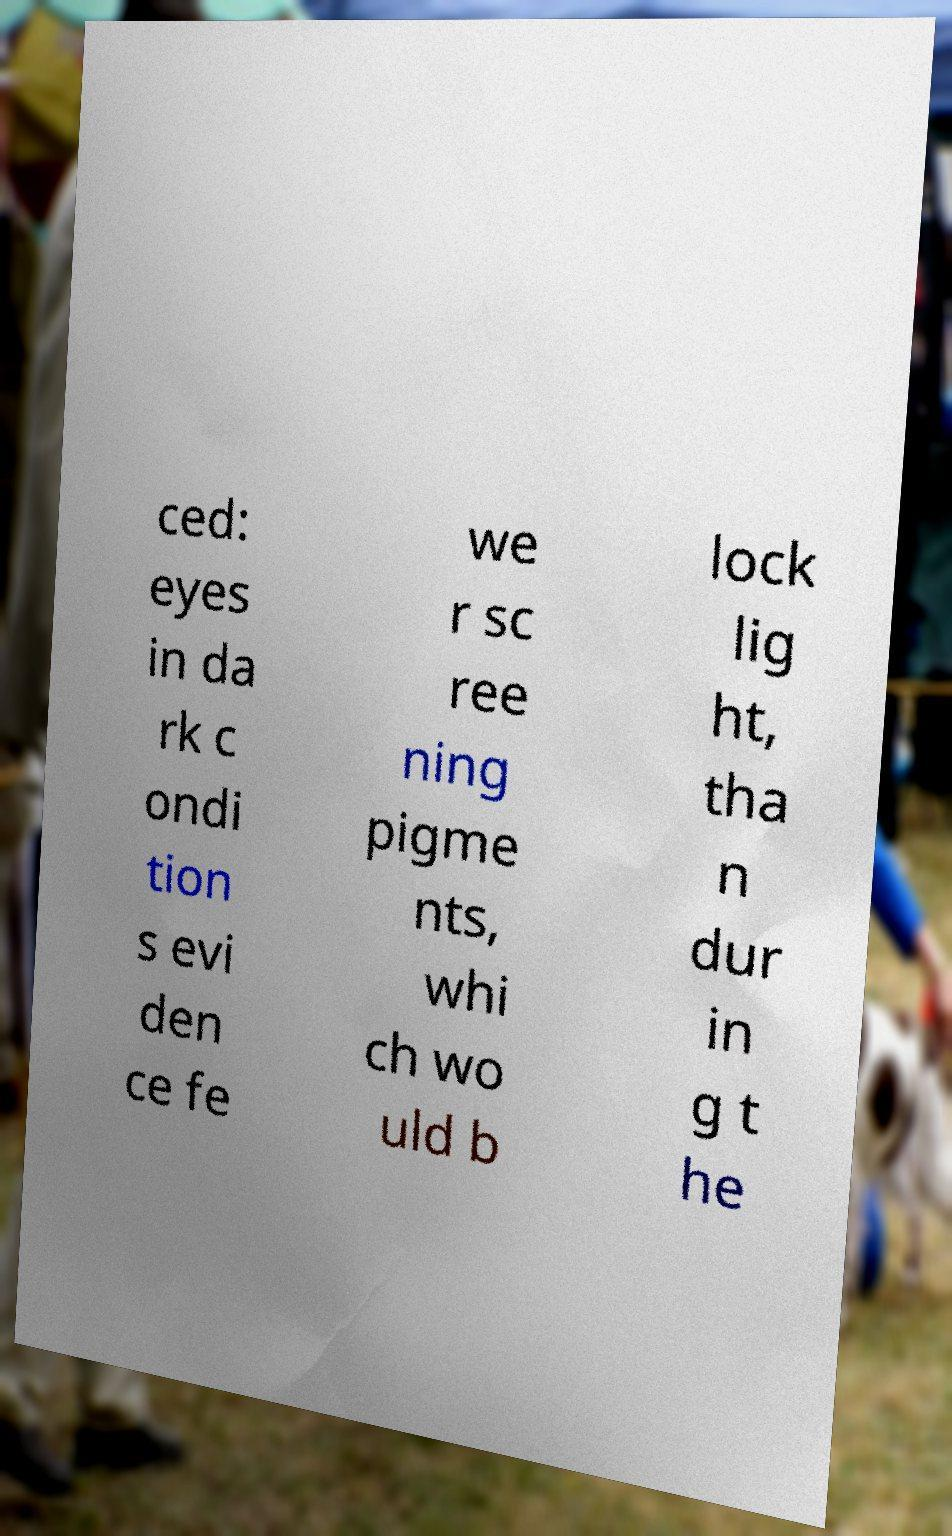Can you read and provide the text displayed in the image?This photo seems to have some interesting text. Can you extract and type it out for me? ced: eyes in da rk c ondi tion s evi den ce fe we r sc ree ning pigme nts, whi ch wo uld b lock lig ht, tha n dur in g t he 